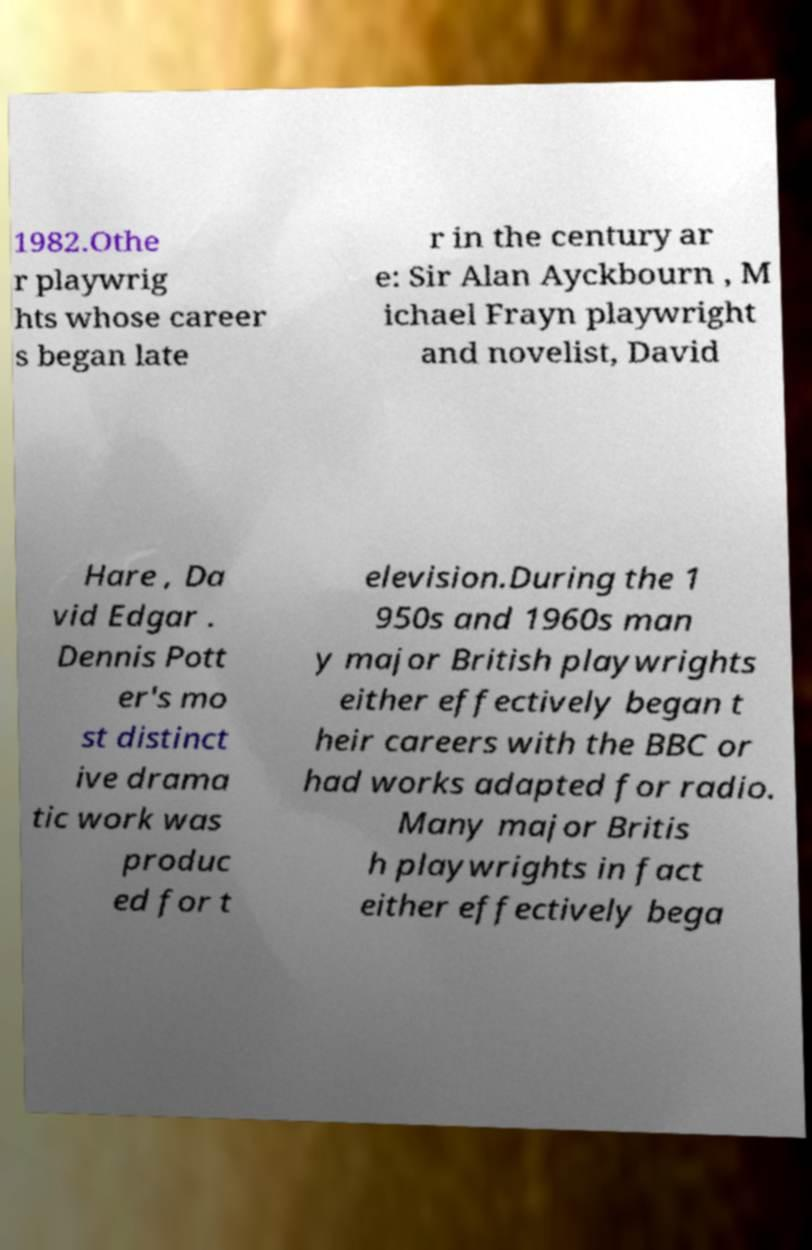Could you assist in decoding the text presented in this image and type it out clearly? 1982.Othe r playwrig hts whose career s began late r in the century ar e: Sir Alan Ayckbourn , M ichael Frayn playwright and novelist, David Hare , Da vid Edgar . Dennis Pott er's mo st distinct ive drama tic work was produc ed for t elevision.During the 1 950s and 1960s man y major British playwrights either effectively began t heir careers with the BBC or had works adapted for radio. Many major Britis h playwrights in fact either effectively bega 